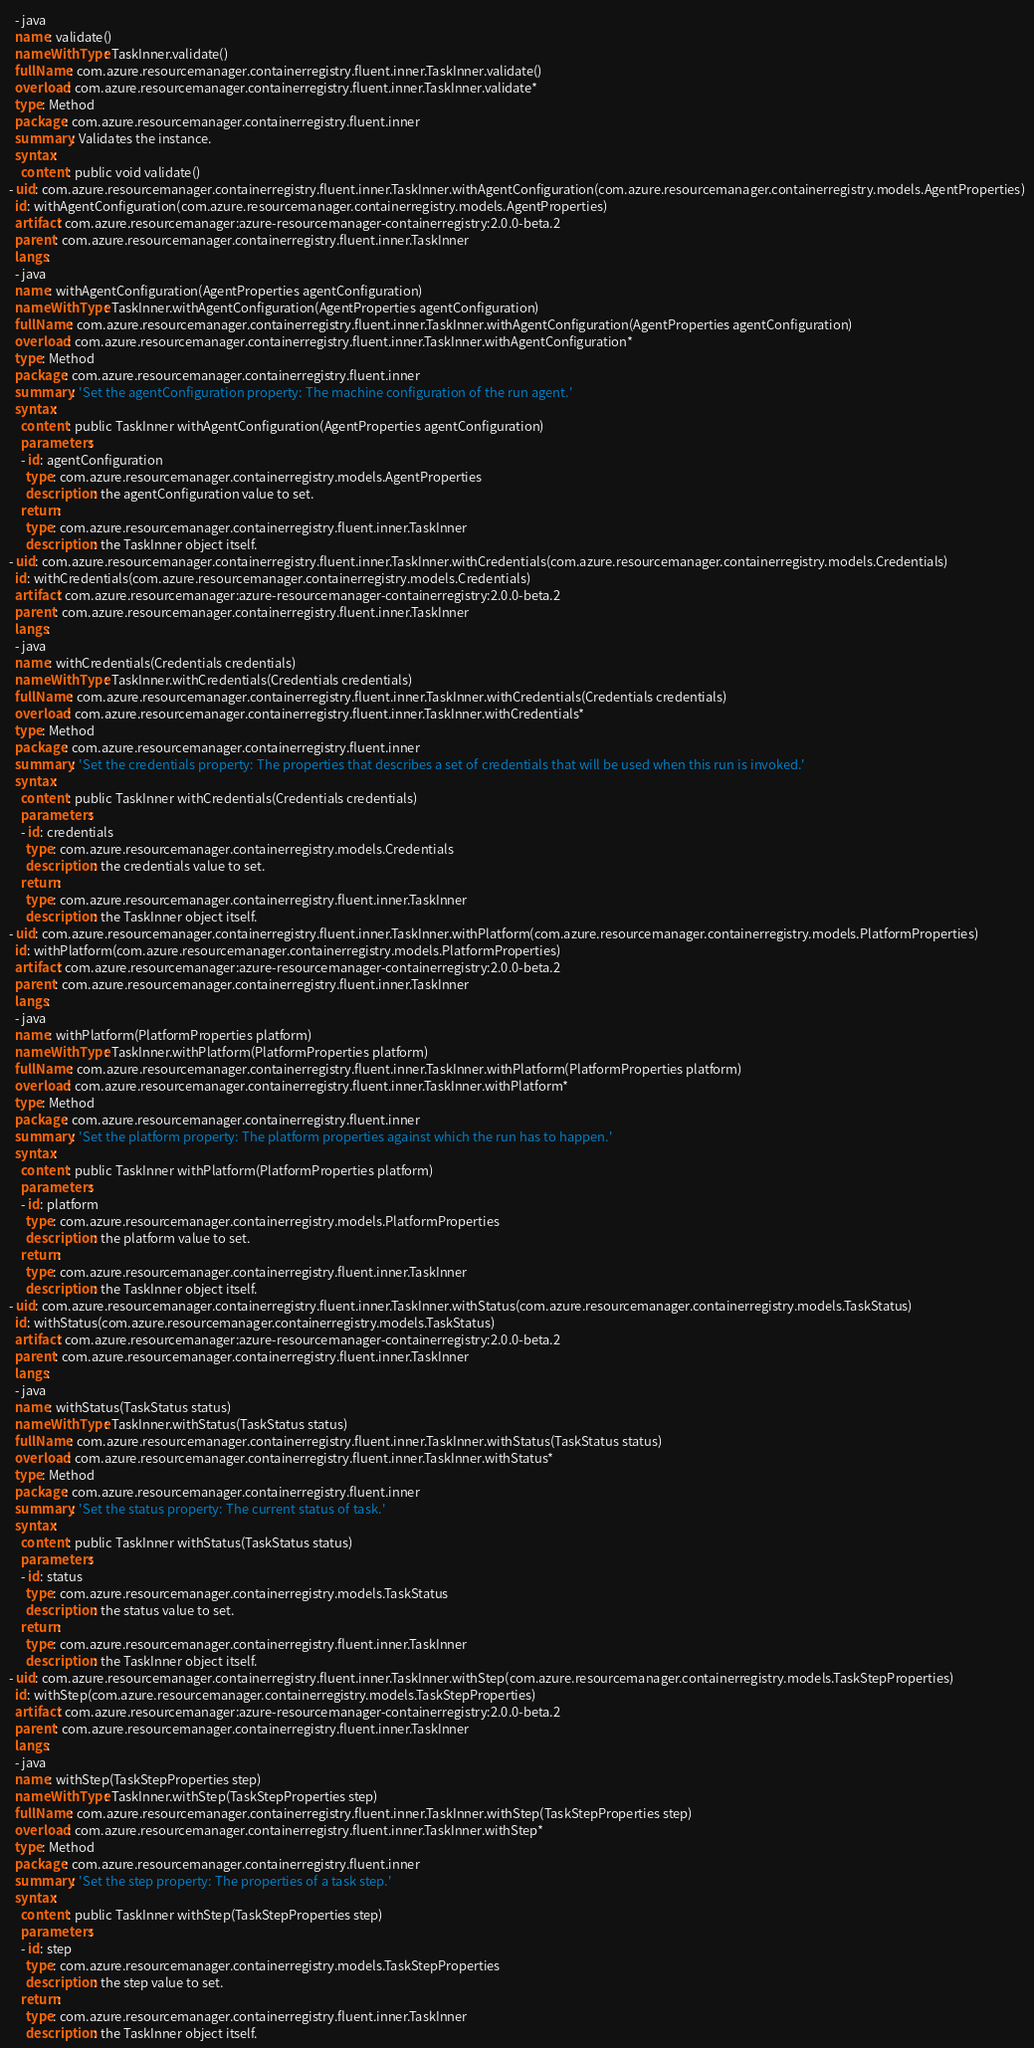Convert code to text. <code><loc_0><loc_0><loc_500><loc_500><_YAML_>  - java
  name: validate()
  nameWithType: TaskInner.validate()
  fullName: com.azure.resourcemanager.containerregistry.fluent.inner.TaskInner.validate()
  overload: com.azure.resourcemanager.containerregistry.fluent.inner.TaskInner.validate*
  type: Method
  package: com.azure.resourcemanager.containerregistry.fluent.inner
  summary: Validates the instance.
  syntax:
    content: public void validate()
- uid: com.azure.resourcemanager.containerregistry.fluent.inner.TaskInner.withAgentConfiguration(com.azure.resourcemanager.containerregistry.models.AgentProperties)
  id: withAgentConfiguration(com.azure.resourcemanager.containerregistry.models.AgentProperties)
  artifact: com.azure.resourcemanager:azure-resourcemanager-containerregistry:2.0.0-beta.2
  parent: com.azure.resourcemanager.containerregistry.fluent.inner.TaskInner
  langs:
  - java
  name: withAgentConfiguration(AgentProperties agentConfiguration)
  nameWithType: TaskInner.withAgentConfiguration(AgentProperties agentConfiguration)
  fullName: com.azure.resourcemanager.containerregistry.fluent.inner.TaskInner.withAgentConfiguration(AgentProperties agentConfiguration)
  overload: com.azure.resourcemanager.containerregistry.fluent.inner.TaskInner.withAgentConfiguration*
  type: Method
  package: com.azure.resourcemanager.containerregistry.fluent.inner
  summary: 'Set the agentConfiguration property: The machine configuration of the run agent.'
  syntax:
    content: public TaskInner withAgentConfiguration(AgentProperties agentConfiguration)
    parameters:
    - id: agentConfiguration
      type: com.azure.resourcemanager.containerregistry.models.AgentProperties
      description: the agentConfiguration value to set.
    return:
      type: com.azure.resourcemanager.containerregistry.fluent.inner.TaskInner
      description: the TaskInner object itself.
- uid: com.azure.resourcemanager.containerregistry.fluent.inner.TaskInner.withCredentials(com.azure.resourcemanager.containerregistry.models.Credentials)
  id: withCredentials(com.azure.resourcemanager.containerregistry.models.Credentials)
  artifact: com.azure.resourcemanager:azure-resourcemanager-containerregistry:2.0.0-beta.2
  parent: com.azure.resourcemanager.containerregistry.fluent.inner.TaskInner
  langs:
  - java
  name: withCredentials(Credentials credentials)
  nameWithType: TaskInner.withCredentials(Credentials credentials)
  fullName: com.azure.resourcemanager.containerregistry.fluent.inner.TaskInner.withCredentials(Credentials credentials)
  overload: com.azure.resourcemanager.containerregistry.fluent.inner.TaskInner.withCredentials*
  type: Method
  package: com.azure.resourcemanager.containerregistry.fluent.inner
  summary: 'Set the credentials property: The properties that describes a set of credentials that will be used when this run is invoked.'
  syntax:
    content: public TaskInner withCredentials(Credentials credentials)
    parameters:
    - id: credentials
      type: com.azure.resourcemanager.containerregistry.models.Credentials
      description: the credentials value to set.
    return:
      type: com.azure.resourcemanager.containerregistry.fluent.inner.TaskInner
      description: the TaskInner object itself.
- uid: com.azure.resourcemanager.containerregistry.fluent.inner.TaskInner.withPlatform(com.azure.resourcemanager.containerregistry.models.PlatformProperties)
  id: withPlatform(com.azure.resourcemanager.containerregistry.models.PlatformProperties)
  artifact: com.azure.resourcemanager:azure-resourcemanager-containerregistry:2.0.0-beta.2
  parent: com.azure.resourcemanager.containerregistry.fluent.inner.TaskInner
  langs:
  - java
  name: withPlatform(PlatformProperties platform)
  nameWithType: TaskInner.withPlatform(PlatformProperties platform)
  fullName: com.azure.resourcemanager.containerregistry.fluent.inner.TaskInner.withPlatform(PlatformProperties platform)
  overload: com.azure.resourcemanager.containerregistry.fluent.inner.TaskInner.withPlatform*
  type: Method
  package: com.azure.resourcemanager.containerregistry.fluent.inner
  summary: 'Set the platform property: The platform properties against which the run has to happen.'
  syntax:
    content: public TaskInner withPlatform(PlatformProperties platform)
    parameters:
    - id: platform
      type: com.azure.resourcemanager.containerregistry.models.PlatformProperties
      description: the platform value to set.
    return:
      type: com.azure.resourcemanager.containerregistry.fluent.inner.TaskInner
      description: the TaskInner object itself.
- uid: com.azure.resourcemanager.containerregistry.fluent.inner.TaskInner.withStatus(com.azure.resourcemanager.containerregistry.models.TaskStatus)
  id: withStatus(com.azure.resourcemanager.containerregistry.models.TaskStatus)
  artifact: com.azure.resourcemanager:azure-resourcemanager-containerregistry:2.0.0-beta.2
  parent: com.azure.resourcemanager.containerregistry.fluent.inner.TaskInner
  langs:
  - java
  name: withStatus(TaskStatus status)
  nameWithType: TaskInner.withStatus(TaskStatus status)
  fullName: com.azure.resourcemanager.containerregistry.fluent.inner.TaskInner.withStatus(TaskStatus status)
  overload: com.azure.resourcemanager.containerregistry.fluent.inner.TaskInner.withStatus*
  type: Method
  package: com.azure.resourcemanager.containerregistry.fluent.inner
  summary: 'Set the status property: The current status of task.'
  syntax:
    content: public TaskInner withStatus(TaskStatus status)
    parameters:
    - id: status
      type: com.azure.resourcemanager.containerregistry.models.TaskStatus
      description: the status value to set.
    return:
      type: com.azure.resourcemanager.containerregistry.fluent.inner.TaskInner
      description: the TaskInner object itself.
- uid: com.azure.resourcemanager.containerregistry.fluent.inner.TaskInner.withStep(com.azure.resourcemanager.containerregistry.models.TaskStepProperties)
  id: withStep(com.azure.resourcemanager.containerregistry.models.TaskStepProperties)
  artifact: com.azure.resourcemanager:azure-resourcemanager-containerregistry:2.0.0-beta.2
  parent: com.azure.resourcemanager.containerregistry.fluent.inner.TaskInner
  langs:
  - java
  name: withStep(TaskStepProperties step)
  nameWithType: TaskInner.withStep(TaskStepProperties step)
  fullName: com.azure.resourcemanager.containerregistry.fluent.inner.TaskInner.withStep(TaskStepProperties step)
  overload: com.azure.resourcemanager.containerregistry.fluent.inner.TaskInner.withStep*
  type: Method
  package: com.azure.resourcemanager.containerregistry.fluent.inner
  summary: 'Set the step property: The properties of a task step.'
  syntax:
    content: public TaskInner withStep(TaskStepProperties step)
    parameters:
    - id: step
      type: com.azure.resourcemanager.containerregistry.models.TaskStepProperties
      description: the step value to set.
    return:
      type: com.azure.resourcemanager.containerregistry.fluent.inner.TaskInner
      description: the TaskInner object itself.</code> 